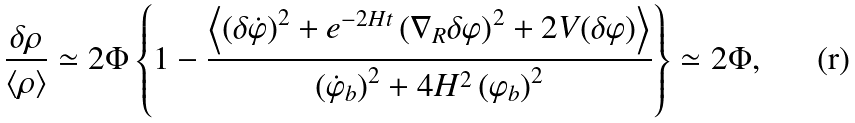Convert formula to latex. <formula><loc_0><loc_0><loc_500><loc_500>\frac { \delta \rho } { \left < \rho \right > } \simeq 2 \Phi \left \{ 1 - \frac { \left < \left ( \delta \dot { \varphi } \right ) ^ { 2 } + e ^ { - 2 H t } \left ( \nabla _ { R } \delta \varphi \right ) ^ { 2 } + 2 V ( \delta \varphi ) \right > } { \left ( \dot { \varphi } _ { b } \right ) ^ { 2 } + 4 H ^ { 2 } \left ( \varphi _ { b } \right ) ^ { 2 } } \right \} \simeq 2 \Phi ,</formula> 